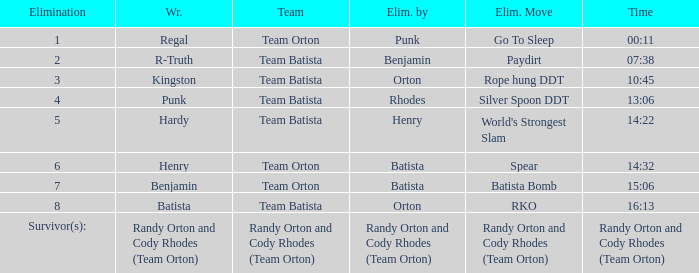Help me parse the entirety of this table. {'header': ['Elimination', 'Wr.', 'Team', 'Elim. by', 'Elim. Move', 'Time'], 'rows': [['1', 'Regal', 'Team Orton', 'Punk', 'Go To Sleep', '00:11'], ['2', 'R-Truth', 'Team Batista', 'Benjamin', 'Paydirt', '07:38'], ['3', 'Kingston', 'Team Batista', 'Orton', 'Rope hung DDT', '10:45'], ['4', 'Punk', 'Team Batista', 'Rhodes', 'Silver Spoon DDT', '13:06'], ['5', 'Hardy', 'Team Batista', 'Henry', "World's Strongest Slam", '14:22'], ['6', 'Henry', 'Team Orton', 'Batista', 'Spear', '14:32'], ['7', 'Benjamin', 'Team Orton', 'Batista', 'Batista Bomb', '15:06'], ['8', 'Batista', 'Team Batista', 'Orton', 'RKO', '16:13'], ['Survivor(s):', 'Randy Orton and Cody Rhodes (Team Orton)', 'Randy Orton and Cody Rhodes (Team Orton)', 'Randy Orton and Cody Rhodes (Team Orton)', 'Randy Orton and Cody Rhodes (Team Orton)', 'Randy Orton and Cody Rhodes (Team Orton)']]} Which Wrestler plays for Team Batista which was Elimated by Orton on Elimination 8? Batista. 